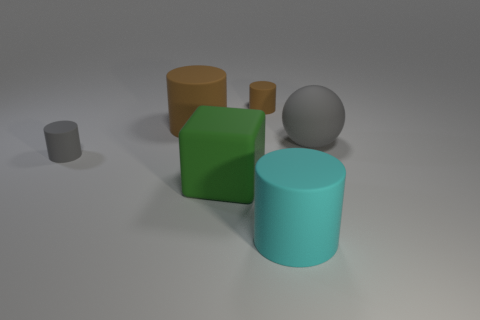Which objects in the scene could potentially roll? In this scene, the object most likely to roll is the grey sphere due to its perfectly round shape. It lacks edges or flat sides that would inhibit rolling. The cylinders, while having curved surfaces, would only roll if they were inclined or pushed due to their flat circular bases. 